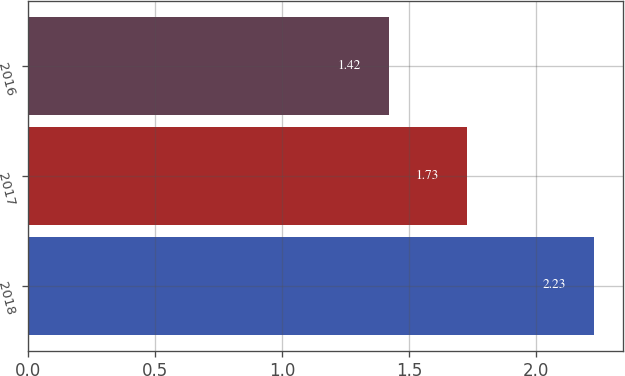<chart> <loc_0><loc_0><loc_500><loc_500><bar_chart><fcel>2018<fcel>2017<fcel>2016<nl><fcel>2.23<fcel>1.73<fcel>1.42<nl></chart> 